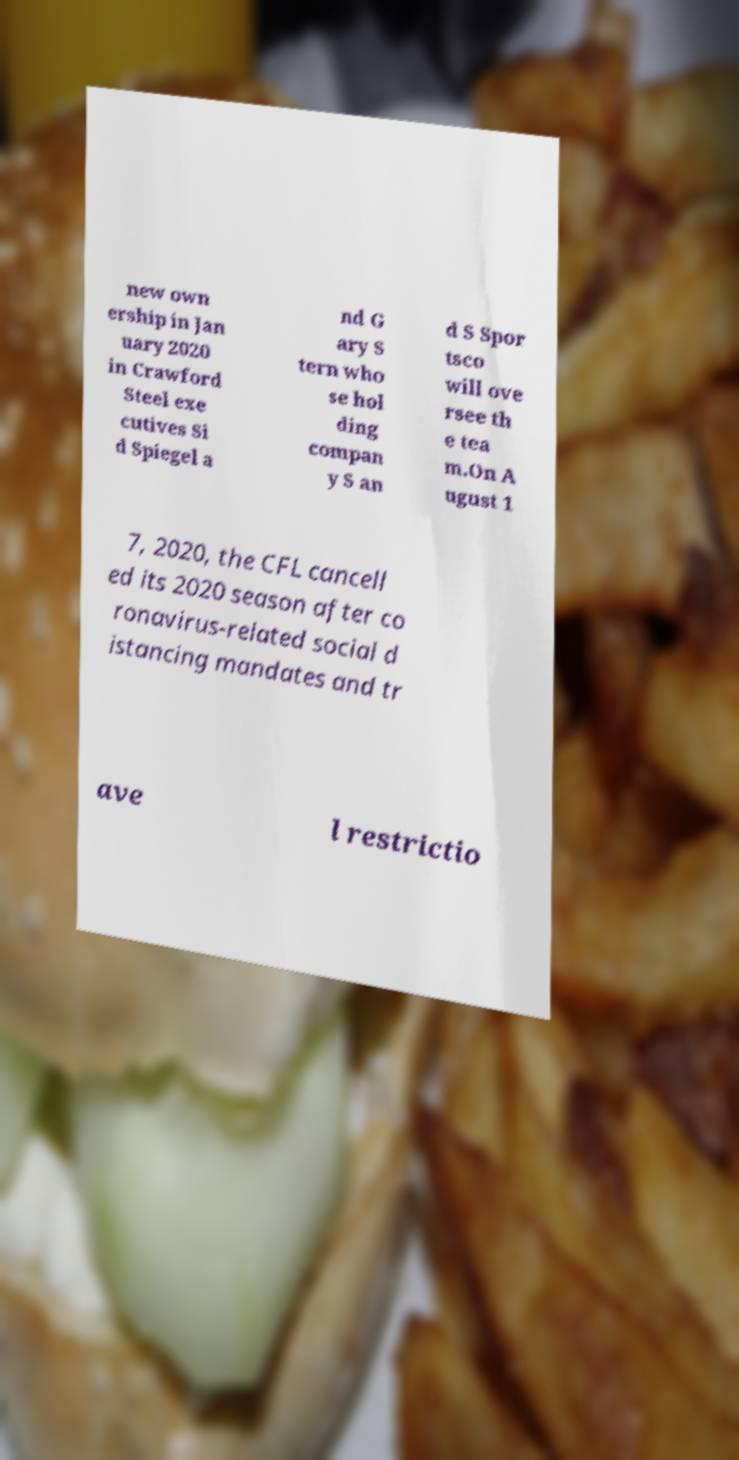Please identify and transcribe the text found in this image. new own ership in Jan uary 2020 in Crawford Steel exe cutives Si d Spiegel a nd G ary S tern who se hol ding compan y S an d S Spor tsco will ove rsee th e tea m.On A ugust 1 7, 2020, the CFL cancell ed its 2020 season after co ronavirus-related social d istancing mandates and tr ave l restrictio 